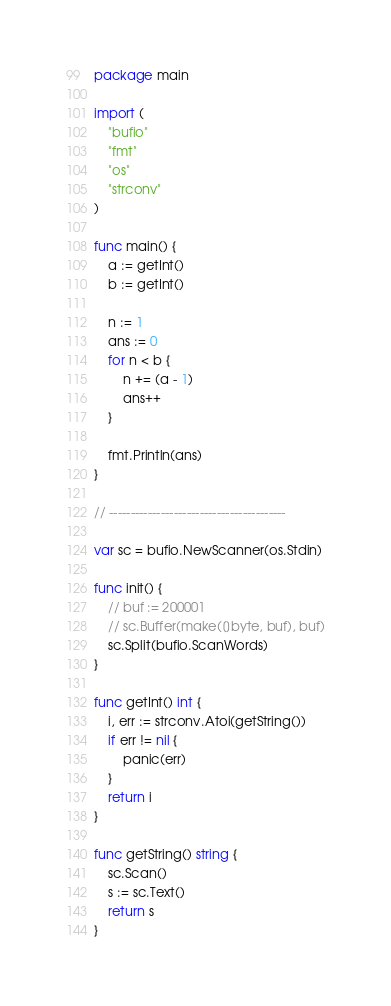<code> <loc_0><loc_0><loc_500><loc_500><_Go_>package main

import (
	"bufio"
	"fmt"
	"os"
	"strconv"
)

func main() {
	a := getInt()
	b := getInt()

	n := 1
	ans := 0
	for n < b {
		n += (a - 1)
		ans++
	}

	fmt.Println(ans)
}

// -----------------------------------------

var sc = bufio.NewScanner(os.Stdin)

func init() {
	// buf := 200001
	// sc.Buffer(make([]byte, buf), buf)
	sc.Split(bufio.ScanWords)
}

func getInt() int {
	i, err := strconv.Atoi(getString())
	if err != nil {
		panic(err)
	}
	return i
}

func getString() string {
	sc.Scan()
	s := sc.Text()
	return s
}
</code> 